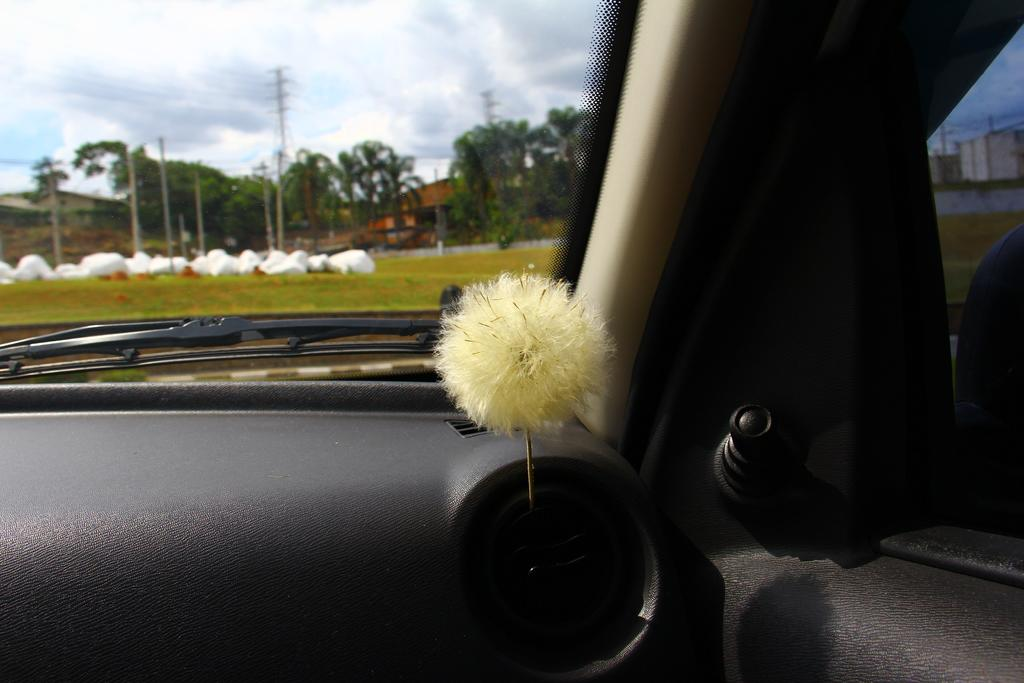What is the main subject of the image? There is a vehicle in the image. What type of natural environment is visible in the image? There is grass, trees, and the sky visible in the image. What type of infrastructure is present in the image? There are current poles, buildings, and the sky visible in the image. What is the condition of the sky in the image? The sky is visible at the top of the image, and clouds are present in the sky. Where is the desk located in the image? There is no desk present in the image. Can you describe the ants crawling on the vehicle in the image? There are no ants present in the image; the vehicle is not shown with any insects or animals. 